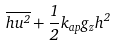<formula> <loc_0><loc_0><loc_500><loc_500>\overline { h u ^ { 2 } } + \frac { 1 } { 2 } k _ { a p } g _ { z } h ^ { 2 }</formula> 